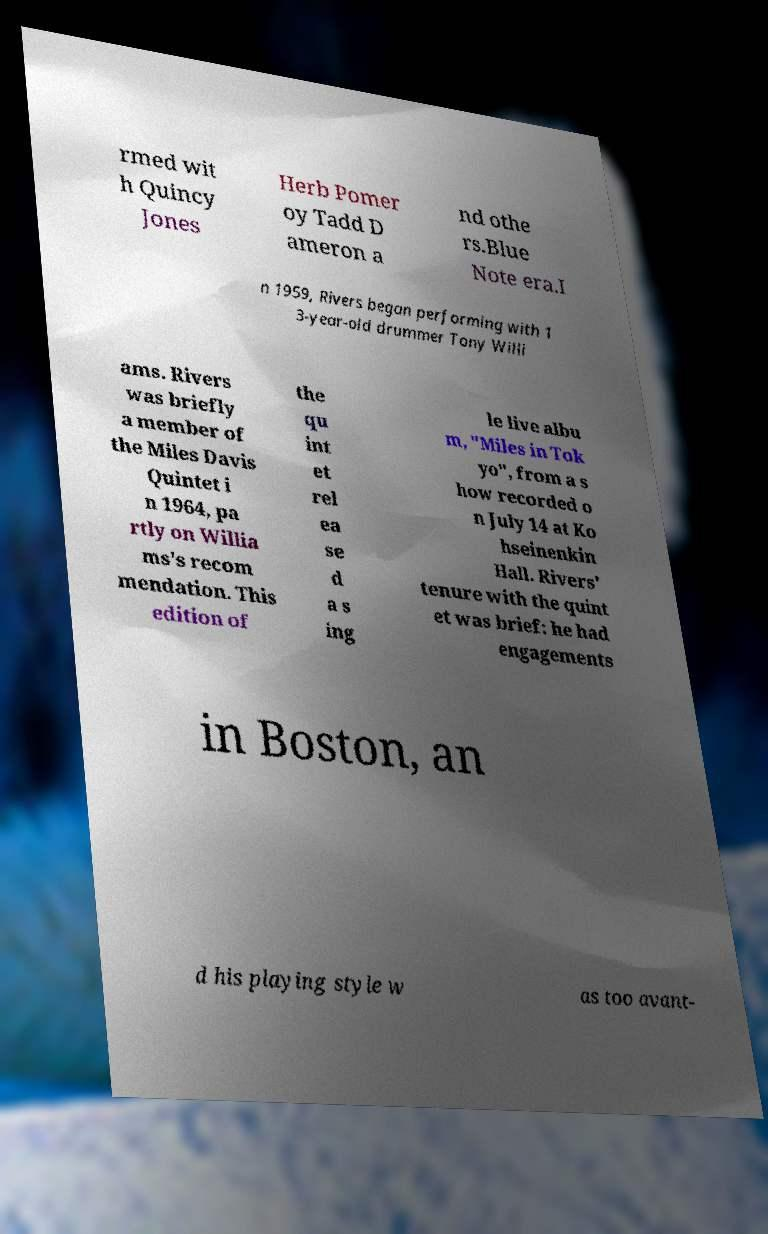I need the written content from this picture converted into text. Can you do that? rmed wit h Quincy Jones Herb Pomer oy Tadd D ameron a nd othe rs.Blue Note era.I n 1959, Rivers began performing with 1 3-year-old drummer Tony Willi ams. Rivers was briefly a member of the Miles Davis Quintet i n 1964, pa rtly on Willia ms's recom mendation. This edition of the qu int et rel ea se d a s ing le live albu m, "Miles in Tok yo", from a s how recorded o n July 14 at Ko hseinenkin Hall. Rivers' tenure with the quint et was brief: he had engagements in Boston, an d his playing style w as too avant- 